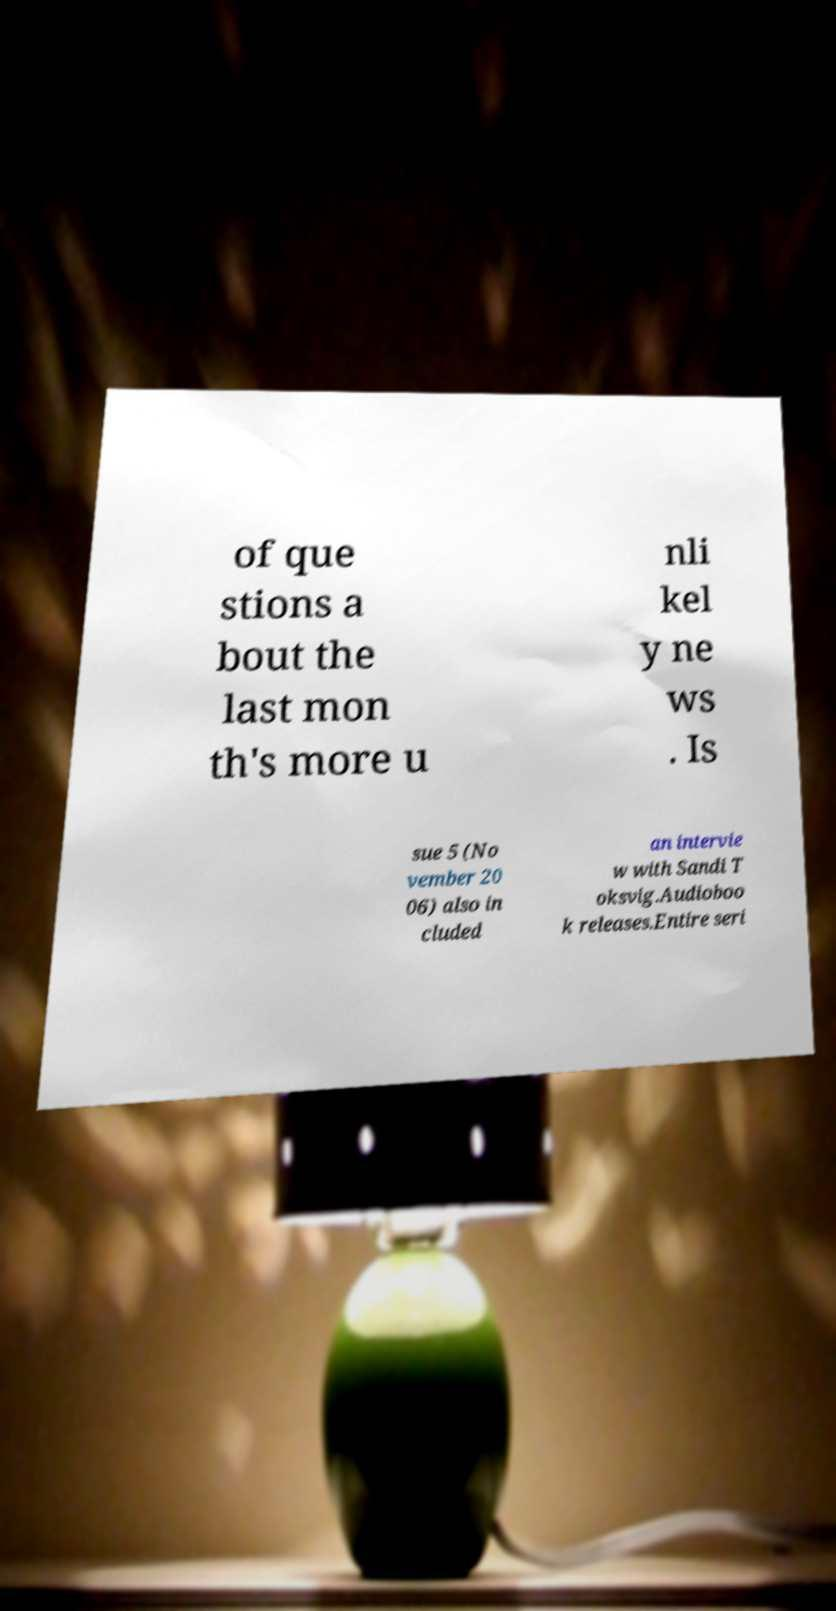Could you extract and type out the text from this image? of que stions a bout the last mon th's more u nli kel y ne ws . Is sue 5 (No vember 20 06) also in cluded an intervie w with Sandi T oksvig.Audioboo k releases.Entire seri 